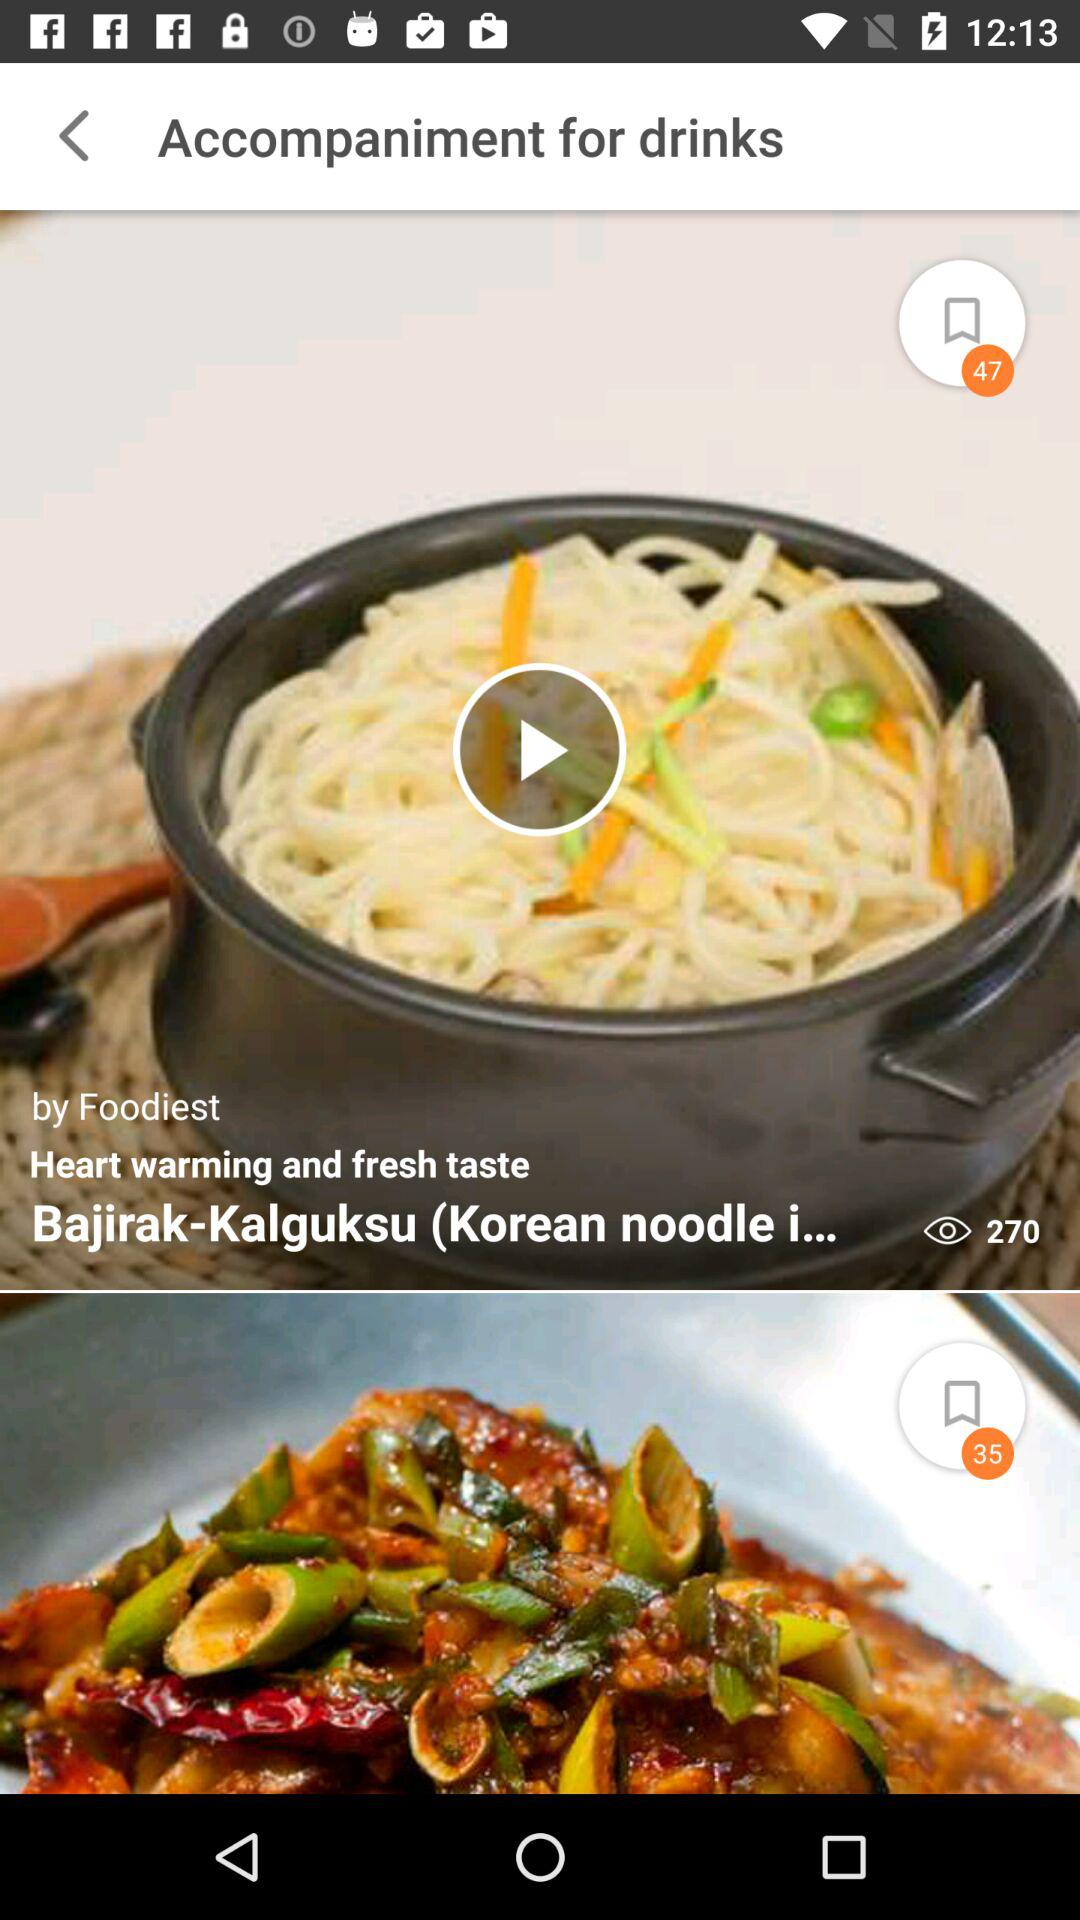By whom was the recipe "Bajirak-Kalguksu" posted? The recipe "Bajirak-Kalguksu" was posted by "Foodiest". 